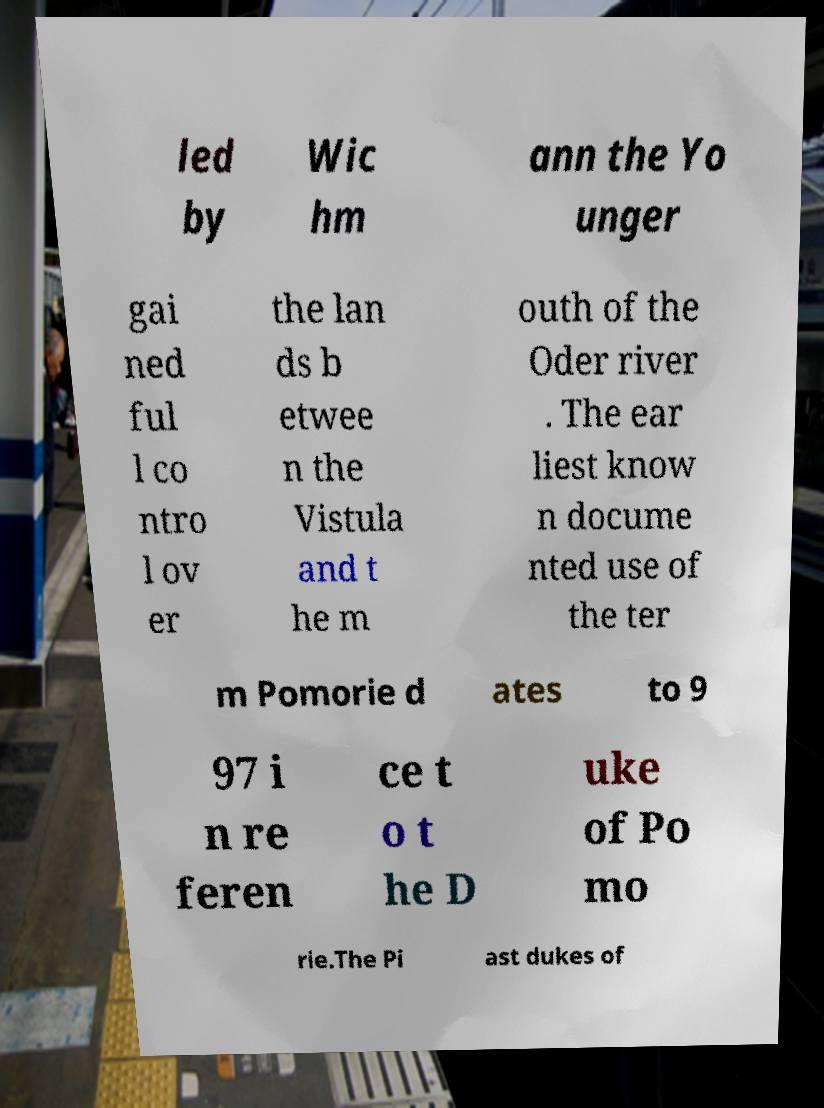For documentation purposes, I need the text within this image transcribed. Could you provide that? led by Wic hm ann the Yo unger gai ned ful l co ntro l ov er the lan ds b etwee n the Vistula and t he m outh of the Oder river . The ear liest know n docume nted use of the ter m Pomorie d ates to 9 97 i n re feren ce t o t he D uke of Po mo rie.The Pi ast dukes of 